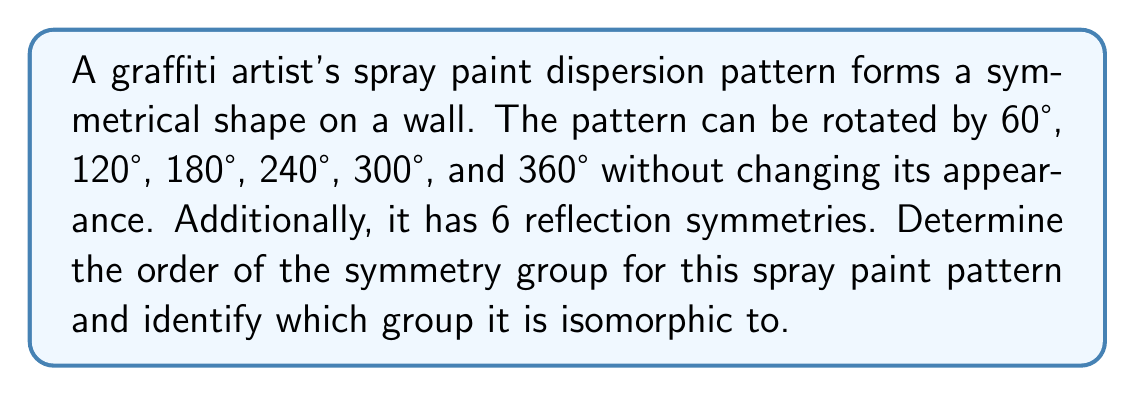Can you answer this question? Let's approach this step-by-step:

1) First, we need to identify the symmetries of the pattern:
   - 6 rotational symmetries: 60°, 120°, 180°, 240°, 300°, 360° (or 0°)
   - 6 reflection symmetries

2) The total number of symmetries is the order of the group. Here, it's 6 + 6 = 12.

3) To identify the group, we need to consider its properties:
   - It has rotational symmetries of order 6 (rotation by 60° generates all other rotations)
   - It has reflection symmetries

4) This combination of symmetries is characteristic of the dihedral group $D_6$.

5) The dihedral group $D_n$ is defined as the group of symmetries of a regular n-gon, including both rotations and reflections.

6) In group theory notation:
   $D_6 = \langle r, s | r^6 = s^2 = 1, srs = r^{-1} \rangle$
   Where $r$ represents rotation and $s$ represents reflection.

7) The order of $D_6$ is indeed 12, which matches our count of symmetries.

Therefore, the symmetry group of the spray paint pattern is isomorphic to the dihedral group $D_6$.
Answer: $D_6$, order 12 